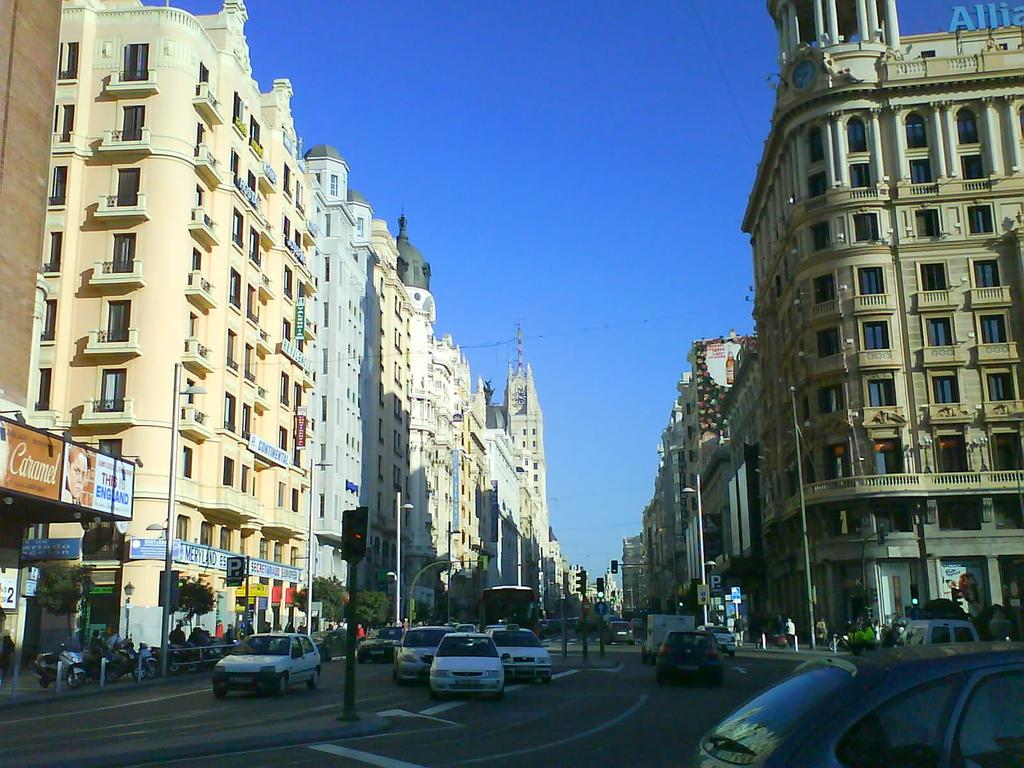What type of structures can be seen in the image? There are buildings in the image. What else is present in the image besides buildings? There are vehicles, poles, lights, trees, and name boards in the image. Can you describe the lighting in the image? There are lights present in the image. What is visible in the background of the image? The sky is visible in the background of the image. Are there any snowflakes visible in the image? There is no snow or snowflakes present in the image. What type of tool is being used to cut the trees in the image? There is no tool or activity involving cutting trees in the image. 